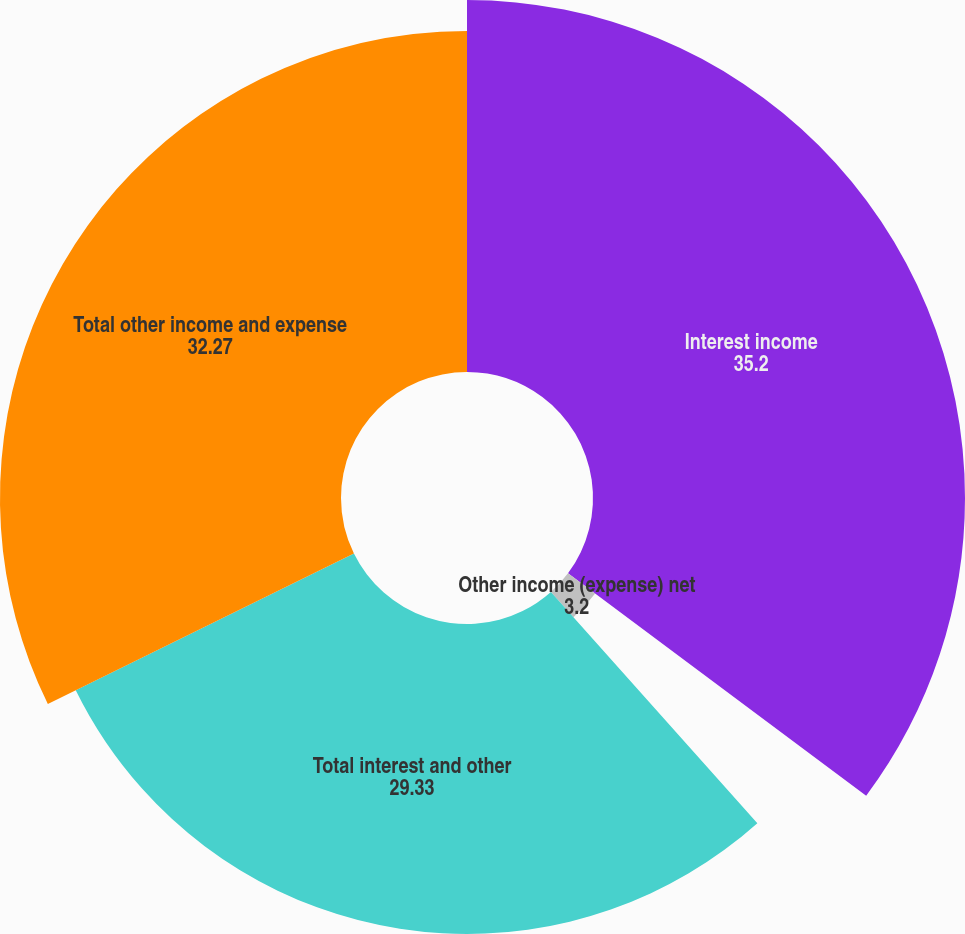Convert chart. <chart><loc_0><loc_0><loc_500><loc_500><pie_chart><fcel>Interest income<fcel>Other income (expense) net<fcel>Total interest and other<fcel>Total other income and expense<nl><fcel>35.2%<fcel>3.2%<fcel>29.33%<fcel>32.27%<nl></chart> 